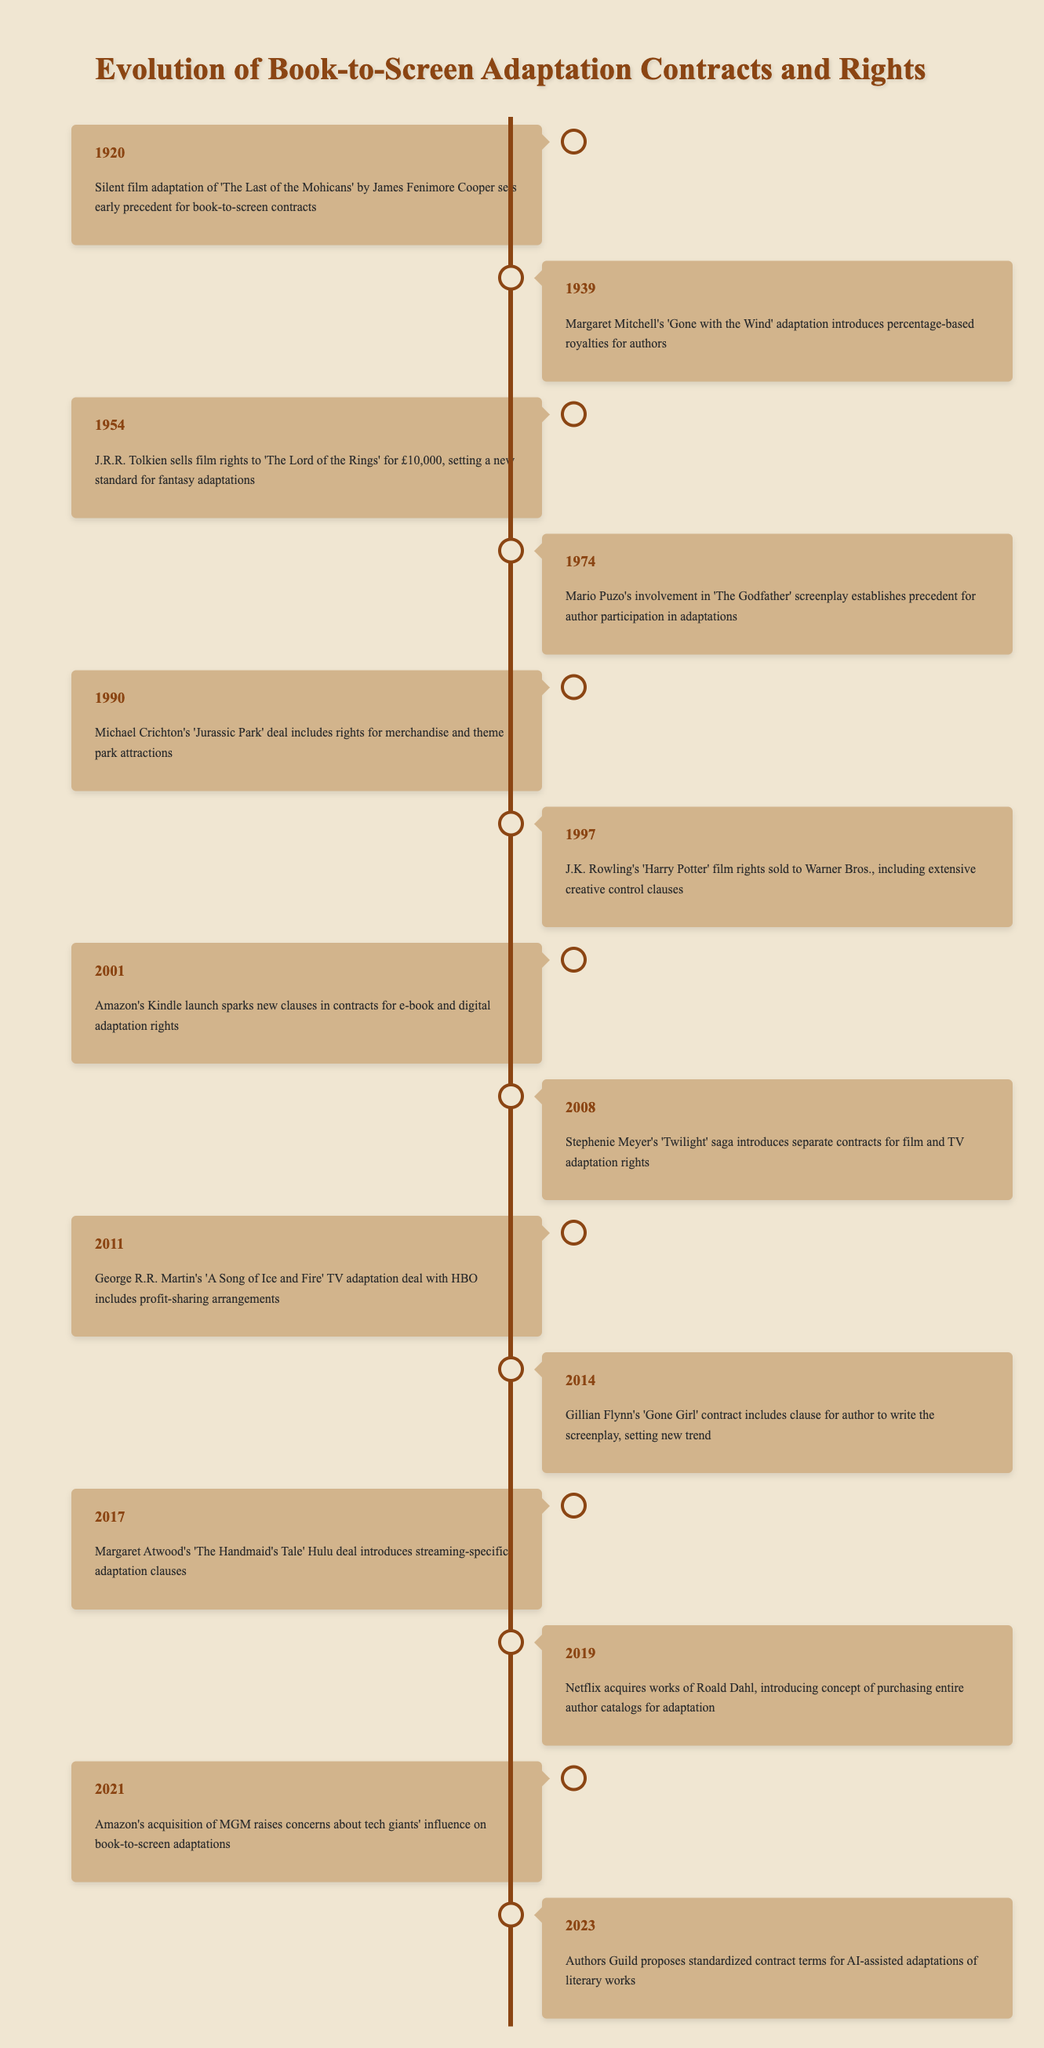What event introduced percentage-based royalties for authors? The table states that in 1939, the adaptation of Margaret Mitchell's 'Gone with the Wind' introduced percentage-based royalties for authors.
Answer: 'Gone with the Wind' adaptation What year did J.K. Rowling sell the film rights to 'Harry Potter'? According to the table, the film rights to J.K. Rowling's 'Harry Potter' were sold to Warner Bros. in 1997.
Answer: 1997 Which adaptations introduced separate contracts for film and TV rights? The table indicates that in 2008, Stephenie Meyer's 'Twilight' saga introduced separate contracts for film and TV adaptation rights.
Answer: Twilight saga How many years passed between the first adaptation precedent in 1920 and the proposal for AI-assisted adaptations in 2023? From 1920 to 2023, there are 103 years that passed (2023 - 1920 = 103).
Answer: 103 Did George R.R. Martin’s deal with HBO include profit-sharing arrangements? According to the table, the deal in 2011 for George R.R. Martin's 'A Song of Ice and Fire' included profit-sharing arrangements, so the answer is yes.
Answer: Yes What was a significant development in 2001 related to digital adaptations? In 2001, the launch of Amazon's Kindle sparked new clauses in contracts for e-book and digital adaptation rights.
Answer: Kindle launch Which author started a trend by having a clause to write the screenplay for their adaptation? The table shows that Gillian Flynn's contract for 'Gone Girl' in 2014 included a clause for the author to write the screenplay.
Answer: Gillian Flynn In what way did the 2017 deal for 'The Handmaid's Tale' differ from previous agreements? The 2017 Hulu deal for 'The Handmaid's Tale' introduced streaming-specific adaptation clauses, differing from previous agreements which did not account for streaming.
Answer: Streaming-specific clauses How many adaptations post-2000 included clauses for author involvement or control? Analyzing the table, both the 2008 'Twilight' saga and the 2014 'Gone Girl' contracts featured clauses that involved author involvement, totaling two adaptations.
Answer: 2 